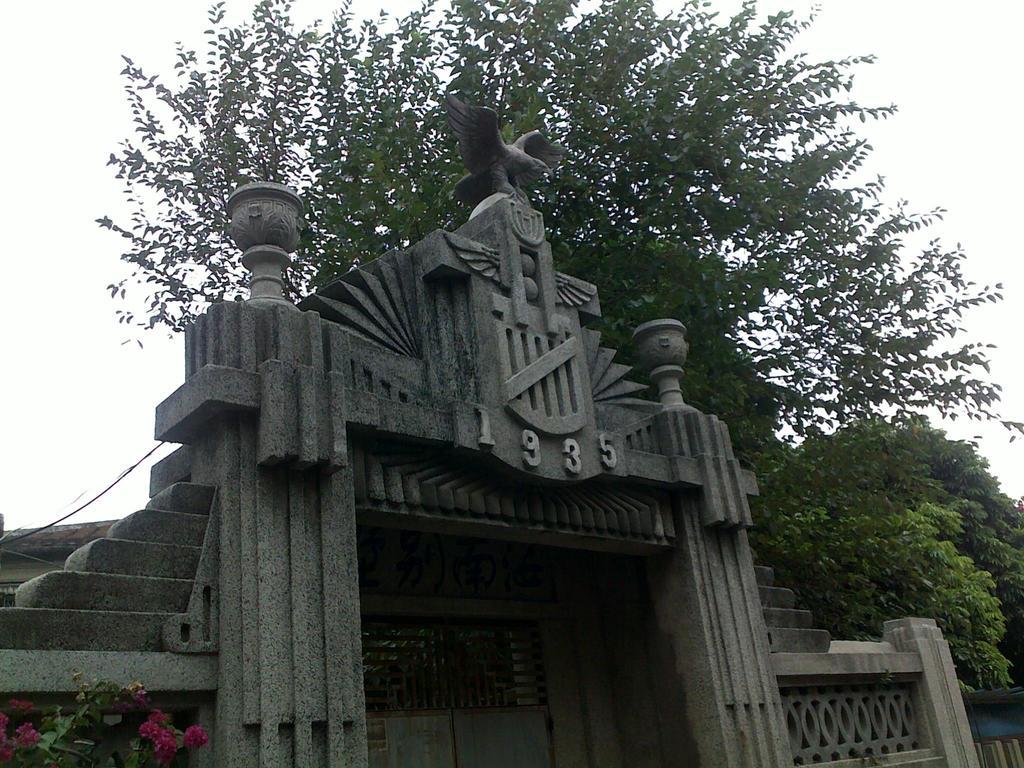What year is on this stone entrance?
Offer a terse response. 1935. 